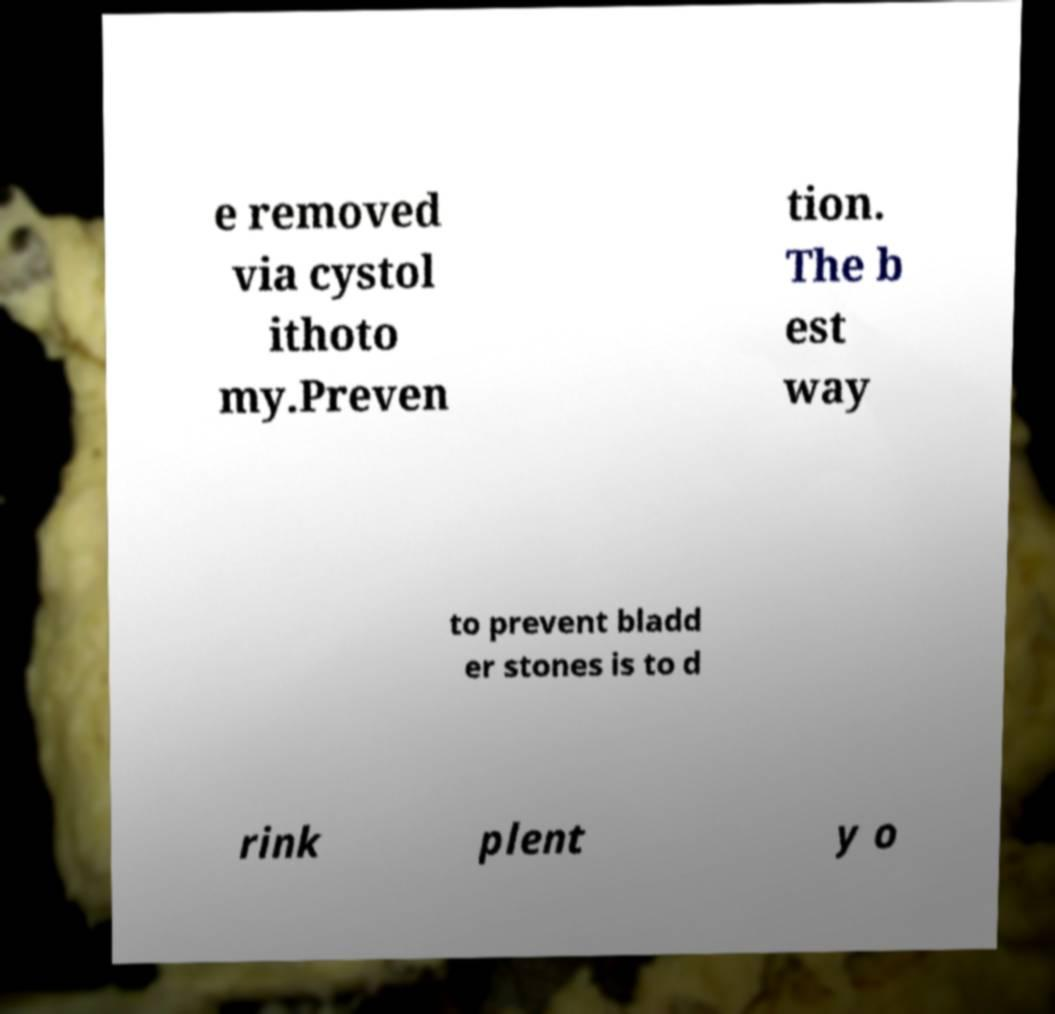Could you extract and type out the text from this image? e removed via cystol ithoto my.Preven tion. The b est way to prevent bladd er stones is to d rink plent y o 